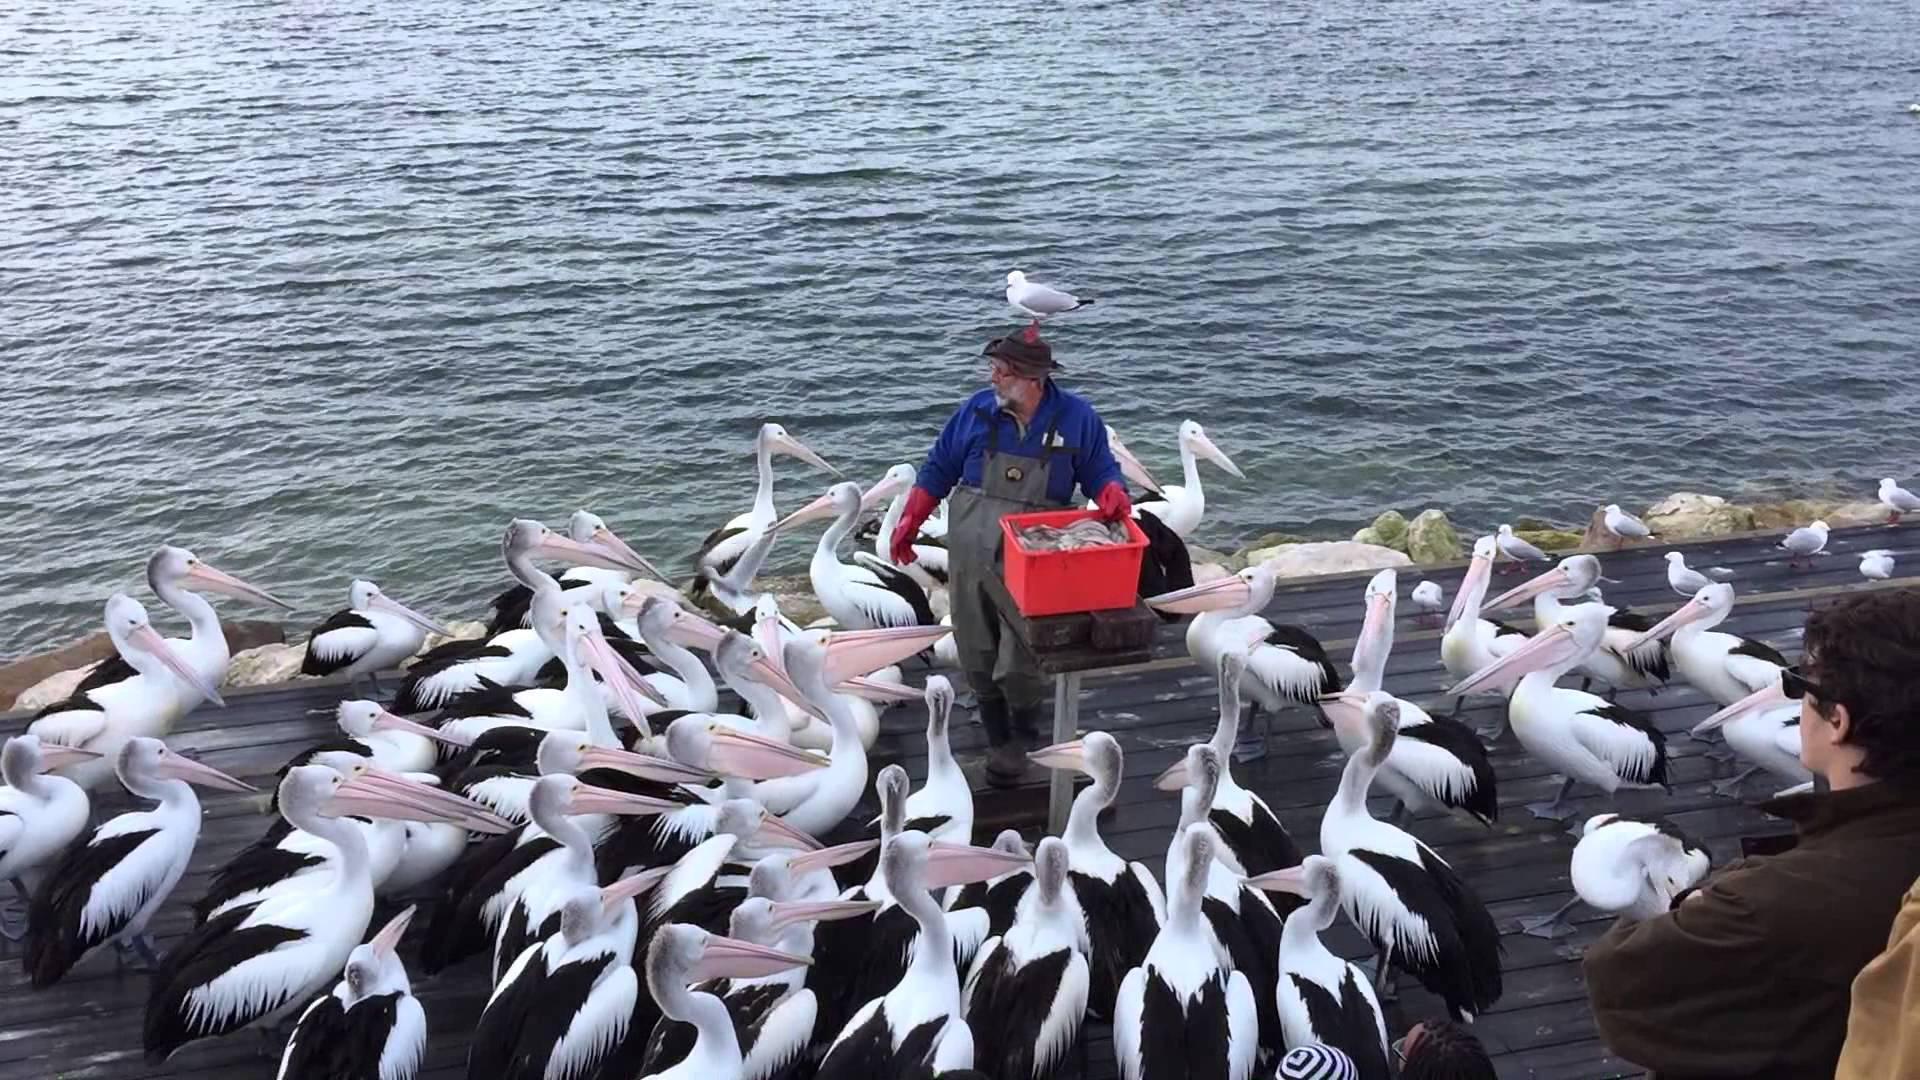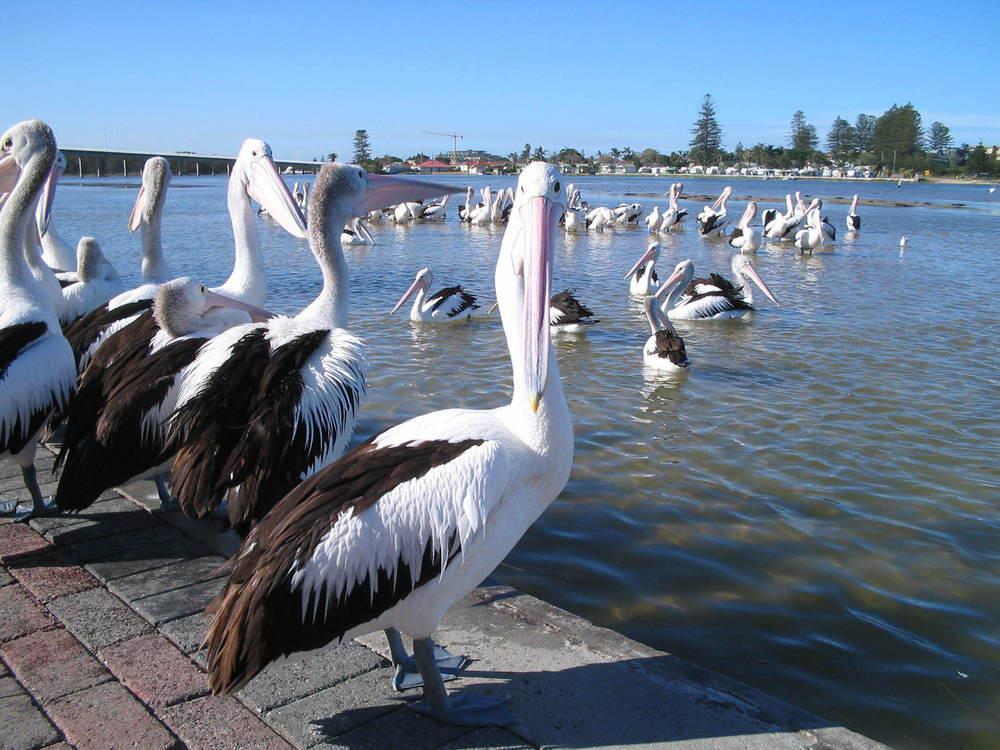The first image is the image on the left, the second image is the image on the right. Examine the images to the left and right. Is the description "Each image shows a single pelican floating on water, and at least one image shows a fish in the bird's bill." accurate? Answer yes or no. No. The first image is the image on the left, the second image is the image on the right. Examine the images to the left and right. Is the description "There is one human interacting with at least one bird in the left image." accurate? Answer yes or no. Yes. 